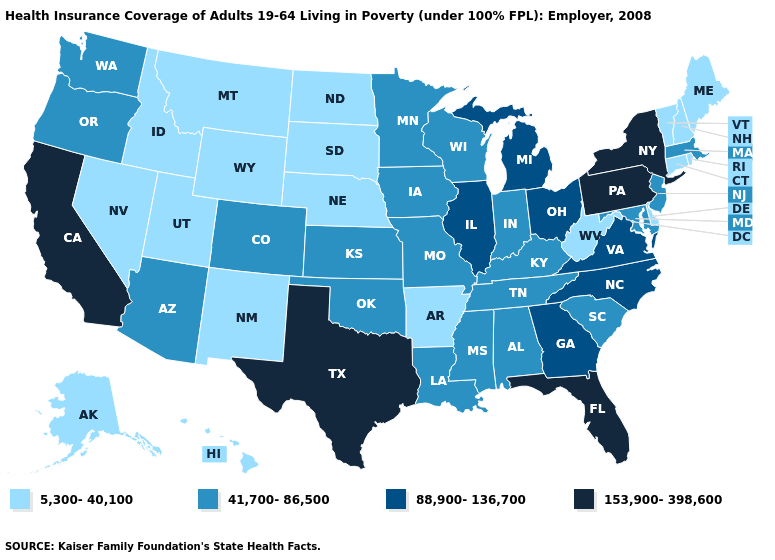Does South Carolina have a higher value than Idaho?
Keep it brief. Yes. What is the value of Arizona?
Give a very brief answer. 41,700-86,500. What is the value of California?
Be succinct. 153,900-398,600. What is the value of Arkansas?
Concise answer only. 5,300-40,100. Does Massachusetts have the same value as Tennessee?
Quick response, please. Yes. Name the states that have a value in the range 153,900-398,600?
Write a very short answer. California, Florida, New York, Pennsylvania, Texas. Name the states that have a value in the range 5,300-40,100?
Short answer required. Alaska, Arkansas, Connecticut, Delaware, Hawaii, Idaho, Maine, Montana, Nebraska, Nevada, New Hampshire, New Mexico, North Dakota, Rhode Island, South Dakota, Utah, Vermont, West Virginia, Wyoming. What is the value of Idaho?
Write a very short answer. 5,300-40,100. What is the highest value in the West ?
Be succinct. 153,900-398,600. Does Arizona have the same value as West Virginia?
Short answer required. No. How many symbols are there in the legend?
Give a very brief answer. 4. What is the lowest value in states that border Oregon?
Be succinct. 5,300-40,100. Name the states that have a value in the range 5,300-40,100?
Give a very brief answer. Alaska, Arkansas, Connecticut, Delaware, Hawaii, Idaho, Maine, Montana, Nebraska, Nevada, New Hampshire, New Mexico, North Dakota, Rhode Island, South Dakota, Utah, Vermont, West Virginia, Wyoming. What is the value of Kansas?
Write a very short answer. 41,700-86,500. Name the states that have a value in the range 88,900-136,700?
Quick response, please. Georgia, Illinois, Michigan, North Carolina, Ohio, Virginia. 